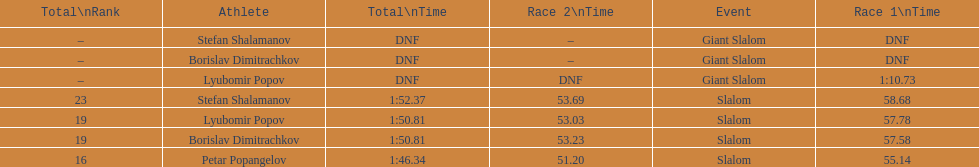How long did it take for lyubomir popov to finish the giant slalom in race 1? 1:10.73. 